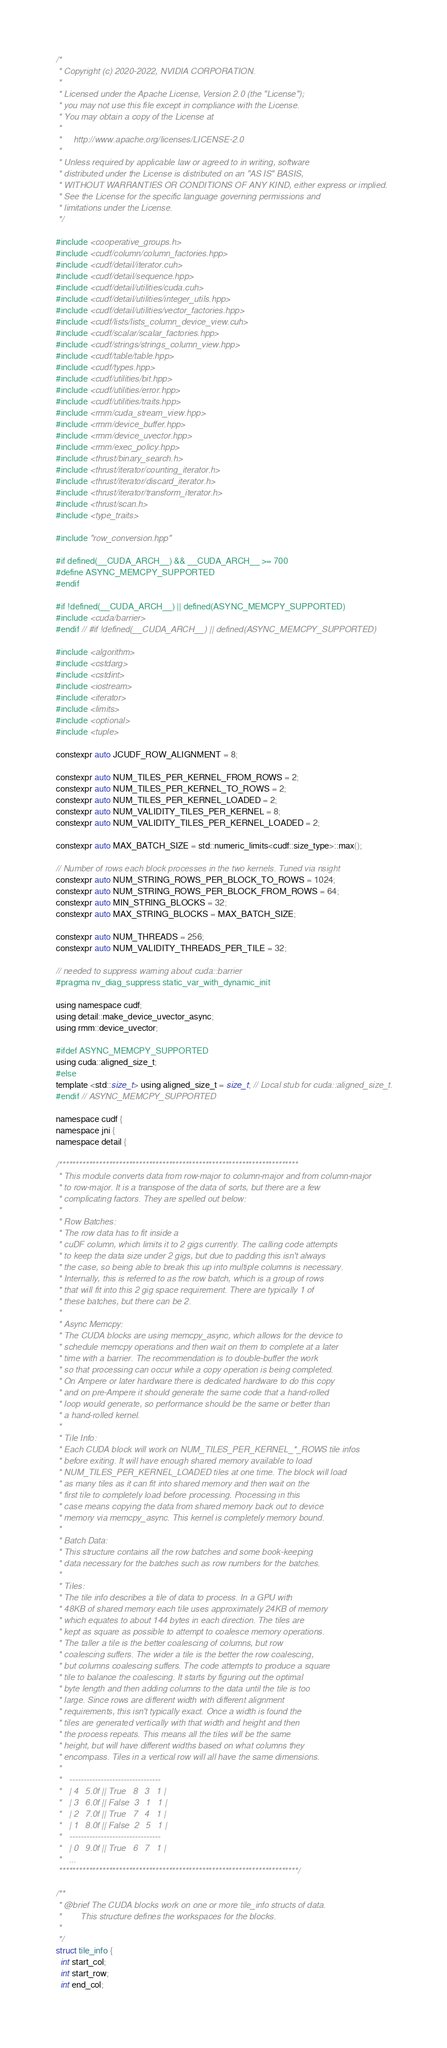<code> <loc_0><loc_0><loc_500><loc_500><_Cuda_>/*
 * Copyright (c) 2020-2022, NVIDIA CORPORATION.
 *
 * Licensed under the Apache License, Version 2.0 (the "License");
 * you may not use this file except in compliance with the License.
 * You may obtain a copy of the License at
 *
 *     http://www.apache.org/licenses/LICENSE-2.0
 *
 * Unless required by applicable law or agreed to in writing, software
 * distributed under the License is distributed on an "AS IS" BASIS,
 * WITHOUT WARRANTIES OR CONDITIONS OF ANY KIND, either express or implied.
 * See the License for the specific language governing permissions and
 * limitations under the License.
 */

#include <cooperative_groups.h>
#include <cudf/column/column_factories.hpp>
#include <cudf/detail/iterator.cuh>
#include <cudf/detail/sequence.hpp>
#include <cudf/detail/utilities/cuda.cuh>
#include <cudf/detail/utilities/integer_utils.hpp>
#include <cudf/detail/utilities/vector_factories.hpp>
#include <cudf/lists/lists_column_device_view.cuh>
#include <cudf/scalar/scalar_factories.hpp>
#include <cudf/strings/strings_column_view.hpp>
#include <cudf/table/table.hpp>
#include <cudf/types.hpp>
#include <cudf/utilities/bit.hpp>
#include <cudf/utilities/error.hpp>
#include <cudf/utilities/traits.hpp>
#include <rmm/cuda_stream_view.hpp>
#include <rmm/device_buffer.hpp>
#include <rmm/device_uvector.hpp>
#include <rmm/exec_policy.hpp>
#include <thrust/binary_search.h>
#include <thrust/iterator/counting_iterator.h>
#include <thrust/iterator/discard_iterator.h>
#include <thrust/iterator/transform_iterator.h>
#include <thrust/scan.h>
#include <type_traits>

#include "row_conversion.hpp"

#if defined(__CUDA_ARCH__) && __CUDA_ARCH__ >= 700
#define ASYNC_MEMCPY_SUPPORTED
#endif

#if !defined(__CUDA_ARCH__) || defined(ASYNC_MEMCPY_SUPPORTED)
#include <cuda/barrier>
#endif // #if !defined(__CUDA_ARCH__) || defined(ASYNC_MEMCPY_SUPPORTED)

#include <algorithm>
#include <cstdarg>
#include <cstdint>
#include <iostream>
#include <iterator>
#include <limits>
#include <optional>
#include <tuple>

constexpr auto JCUDF_ROW_ALIGNMENT = 8;

constexpr auto NUM_TILES_PER_KERNEL_FROM_ROWS = 2;
constexpr auto NUM_TILES_PER_KERNEL_TO_ROWS = 2;
constexpr auto NUM_TILES_PER_KERNEL_LOADED = 2;
constexpr auto NUM_VALIDITY_TILES_PER_KERNEL = 8;
constexpr auto NUM_VALIDITY_TILES_PER_KERNEL_LOADED = 2;

constexpr auto MAX_BATCH_SIZE = std::numeric_limits<cudf::size_type>::max();

// Number of rows each block processes in the two kernels. Tuned via nsight
constexpr auto NUM_STRING_ROWS_PER_BLOCK_TO_ROWS = 1024;
constexpr auto NUM_STRING_ROWS_PER_BLOCK_FROM_ROWS = 64;
constexpr auto MIN_STRING_BLOCKS = 32;
constexpr auto MAX_STRING_BLOCKS = MAX_BATCH_SIZE;

constexpr auto NUM_THREADS = 256;
constexpr auto NUM_VALIDITY_THREADS_PER_TILE = 32;

// needed to suppress warning about cuda::barrier
#pragma nv_diag_suppress static_var_with_dynamic_init

using namespace cudf;
using detail::make_device_uvector_async;
using rmm::device_uvector;

#ifdef ASYNC_MEMCPY_SUPPORTED
using cuda::aligned_size_t;
#else
template <std::size_t> using aligned_size_t = size_t; // Local stub for cuda::aligned_size_t.
#endif // ASYNC_MEMCPY_SUPPORTED

namespace cudf {
namespace jni {
namespace detail {

/************************************************************************
 * This module converts data from row-major to column-major and from column-major
 * to row-major. It is a transpose of the data of sorts, but there are a few
 * complicating factors. They are spelled out below:
 *
 * Row Batches:
 * The row data has to fit inside a
 * cuDF column, which limits it to 2 gigs currently. The calling code attempts
 * to keep the data size under 2 gigs, but due to padding this isn't always
 * the case, so being able to break this up into multiple columns is necessary.
 * Internally, this is referred to as the row batch, which is a group of rows
 * that will fit into this 2 gig space requirement. There are typically 1 of
 * these batches, but there can be 2.
 *
 * Async Memcpy:
 * The CUDA blocks are using memcpy_async, which allows for the device to
 * schedule memcpy operations and then wait on them to complete at a later
 * time with a barrier. The recommendation is to double-buffer the work
 * so that processing can occur while a copy operation is being completed.
 * On Ampere or later hardware there is dedicated hardware to do this copy
 * and on pre-Ampere it should generate the same code that a hand-rolled
 * loop would generate, so performance should be the same or better than
 * a hand-rolled kernel.
 *
 * Tile Info:
 * Each CUDA block will work on NUM_TILES_PER_KERNEL_*_ROWS tile infos
 * before exiting. It will have enough shared memory available to load
 * NUM_TILES_PER_KERNEL_LOADED tiles at one time. The block will load
 * as many tiles as it can fit into shared memory and then wait on the
 * first tile to completely load before processing. Processing in this
 * case means copying the data from shared memory back out to device
 * memory via memcpy_async. This kernel is completely memory bound.
 *
 * Batch Data:
 * This structure contains all the row batches and some book-keeping
 * data necessary for the batches such as row numbers for the batches.
 *
 * Tiles:
 * The tile info describes a tile of data to process. In a GPU with
 * 48KB of shared memory each tile uses approximately 24KB of memory
 * which equates to about 144 bytes in each direction. The tiles are
 * kept as square as possible to attempt to coalesce memory operations.
 * The taller a tile is the better coalescing of columns, but row
 * coalescing suffers. The wider a tile is the better the row coalescing,
 * but columns coalescing suffers. The code attempts to produce a square
 * tile to balance the coalescing. It starts by figuring out the optimal
 * byte length and then adding columns to the data until the tile is too
 * large. Since rows are different width with different alignment
 * requirements, this isn't typically exact. Once a width is found the
 * tiles are generated vertically with that width and height and then
 * the process repeats. This means all the tiles will be the same
 * height, but will have different widths based on what columns they
 * encompass. Tiles in a vertical row will all have the same dimensions.
 *
 *   --------------------------------
 *   | 4   5.0f || True   8   3   1 |
 *   | 3   6.0f || False  3   1   1 |
 *   | 2   7.0f || True   7   4   1 |
 *   | 1   8.0f || False  2   5   1 |
 *   --------------------------------
 *   | 0   9.0f || True   6   7   1 |
 *   ...
 ************************************************************************/

/**
 * @brief The CUDA blocks work on one or more tile_info structs of data.
 *        This structure defines the workspaces for the blocks.
 *
 */
struct tile_info {
  int start_col;
  int start_row;
  int end_col;</code> 